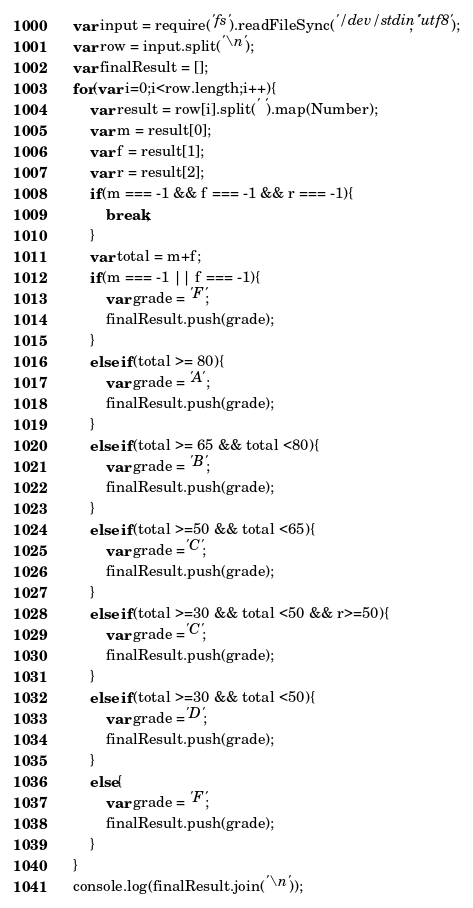Convert code to text. <code><loc_0><loc_0><loc_500><loc_500><_JavaScript_>var input = require('fs').readFileSync('/dev/stdin', 'utf8');
var row = input.split('\n');
var finalResult = [];
for(var i=0;i<row.length;i++){
    var result = row[i].split(' ').map(Number);
    var m = result[0];
    var f = result[1];
    var r = result[2];
    if(m === -1 && f === -1 && r === -1){
        break;
    }
    var total = m+f;
    if(m === -1 || f === -1){
        var grade = 'F';
        finalResult.push(grade);
    }
    else if(total >= 80){
        var grade = 'A';
        finalResult.push(grade);
    }
    else if(total >= 65 && total <80){
        var grade = 'B';
        finalResult.push(grade);
    }
    else if(total >=50 && total <65){
        var grade ='C';
        finalResult.push(grade);
    }
    else if(total >=30 && total <50 && r>=50){
        var grade ='C';
        finalResult.push(grade);
    }
    else if(total >=30 && total <50){
        var grade ='D';
        finalResult.push(grade);
    }
    else{
        var grade = 'F';
        finalResult.push(grade);
    }
}
console.log(finalResult.join('\n'));
</code> 